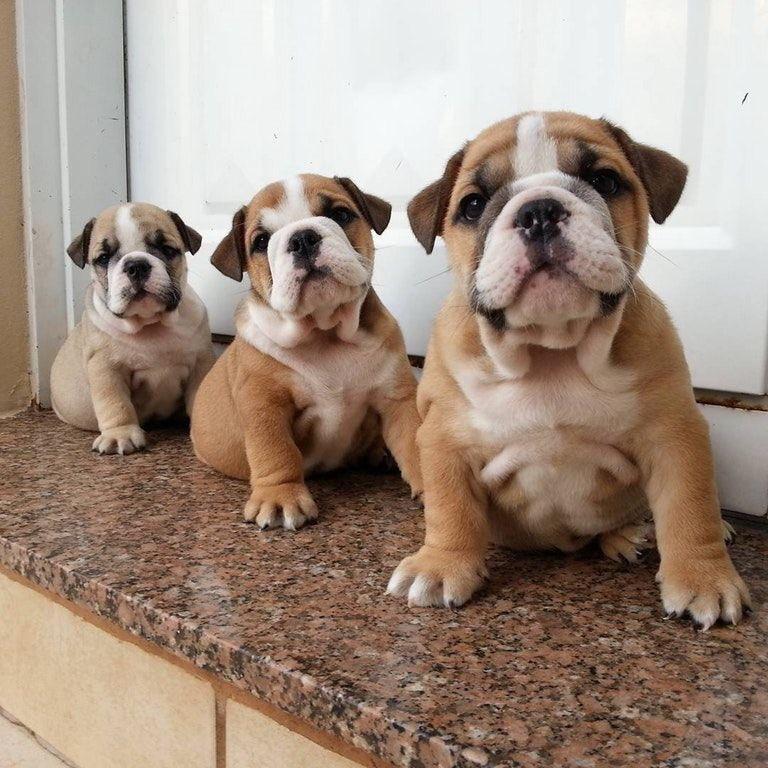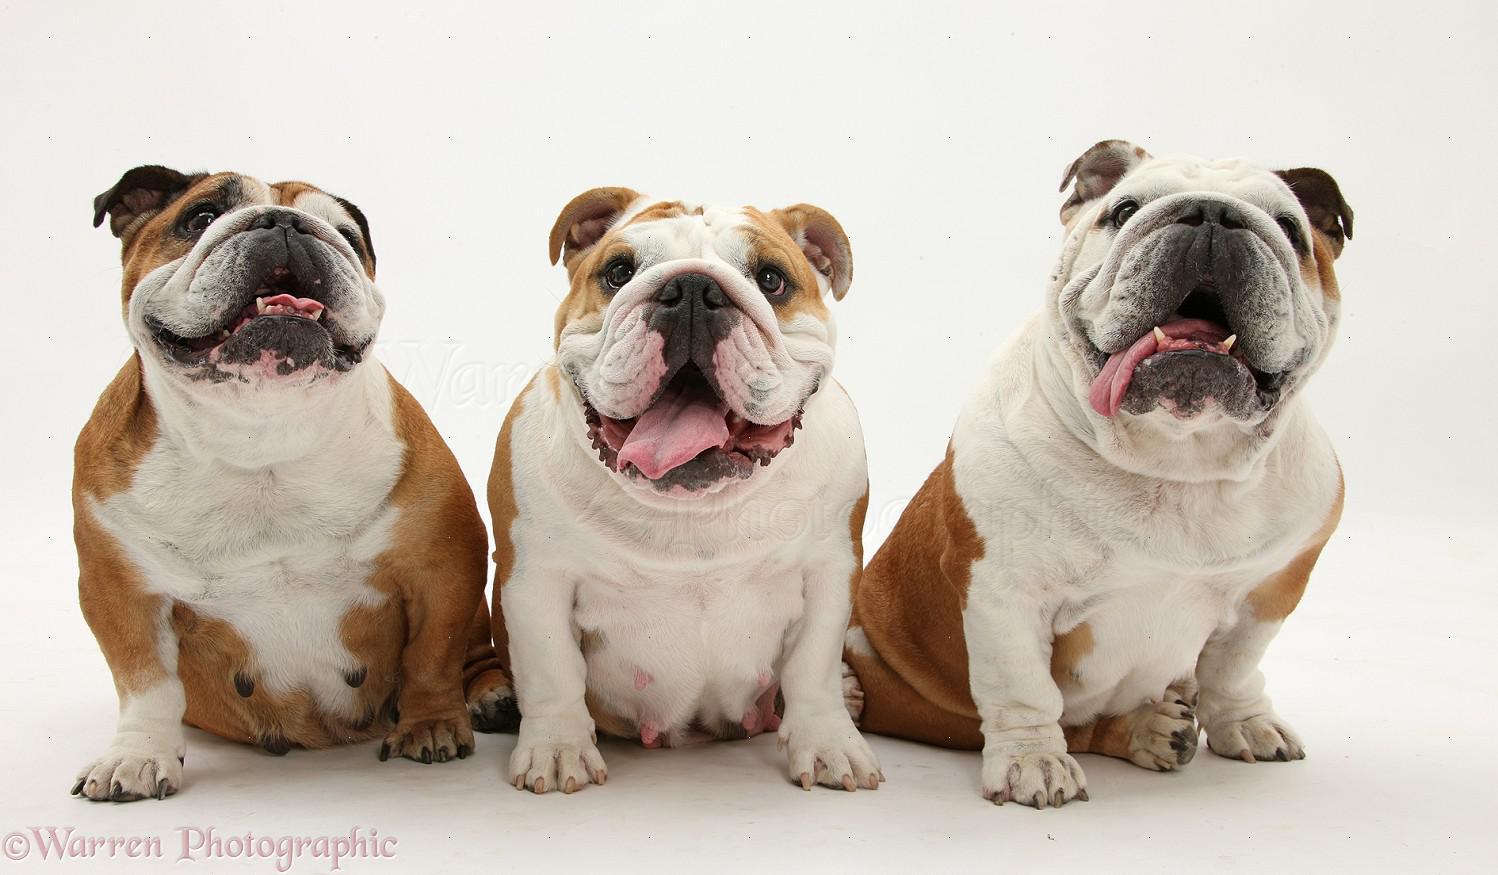The first image is the image on the left, the second image is the image on the right. Analyze the images presented: Is the assertion "The right image contains exactly three bulldogs." valid? Answer yes or no. Yes. The first image is the image on the left, the second image is the image on the right. Analyze the images presented: Is the assertion "There are exactly three bulldogs in each image" valid? Answer yes or no. Yes. 